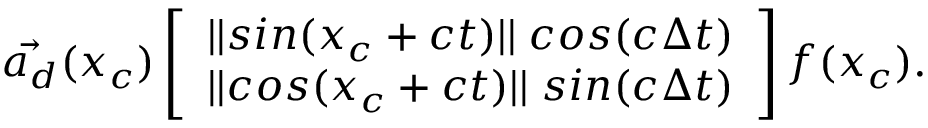<formula> <loc_0><loc_0><loc_500><loc_500>\ V e c { a _ { d } } ( x _ { c } ) \left [ \begin{array} { l } { | | \sin ( x _ { c } + c t ) | | \, \cos ( c \Delta t ) } \\ { | | \cos ( x _ { c } + c t ) | | \, \sin ( c \Delta t ) } \end{array} \right ] f ( x _ { c } ) .</formula> 